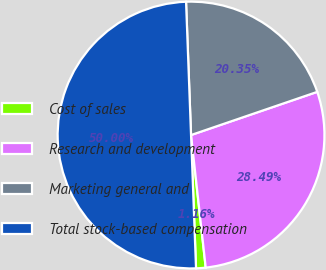<chart> <loc_0><loc_0><loc_500><loc_500><pie_chart><fcel>Cost of sales<fcel>Research and development<fcel>Marketing general and<fcel>Total stock-based compensation<nl><fcel>1.16%<fcel>28.49%<fcel>20.35%<fcel>50.0%<nl></chart> 